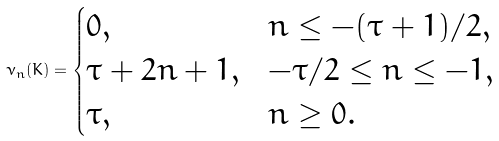Convert formula to latex. <formula><loc_0><loc_0><loc_500><loc_500>\nu _ { n } ( K ) = \begin{cases} 0 , & n \leq - ( \tau + 1 ) / 2 , \\ \tau + 2 n + 1 , & - \tau / 2 \leq n \leq - 1 , \\ \tau , & n \geq 0 . \end{cases}</formula> 